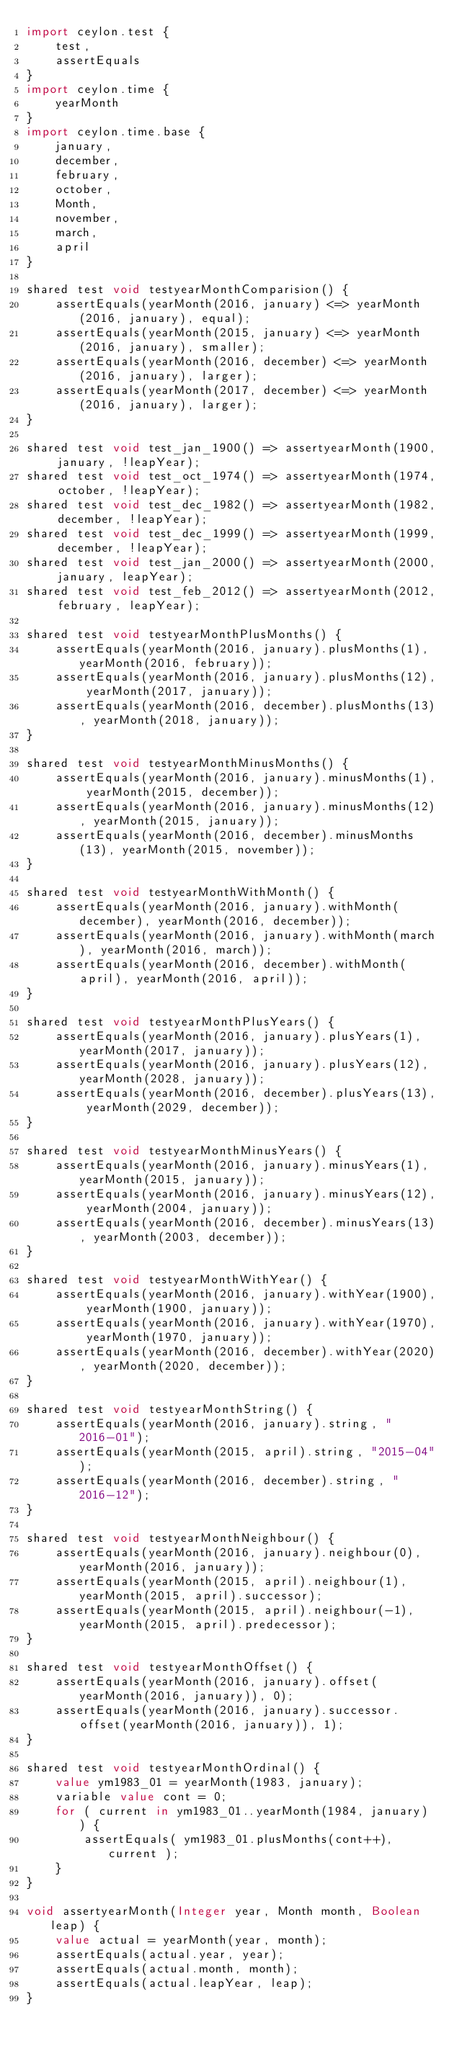Convert code to text. <code><loc_0><loc_0><loc_500><loc_500><_Ceylon_>import ceylon.test {
    test,
    assertEquals
}
import ceylon.time {
    yearMonth
}
import ceylon.time.base {
    january,
    december,
    february,
    october,
    Month,
    november,
    march,
    april
}

shared test void testyearMonthComparision() {
    assertEquals(yearMonth(2016, january) <=> yearMonth(2016, january), equal);
    assertEquals(yearMonth(2015, january) <=> yearMonth(2016, january), smaller);
    assertEquals(yearMonth(2016, december) <=> yearMonth(2016, january), larger);
    assertEquals(yearMonth(2017, december) <=> yearMonth(2016, january), larger);
}

shared test void test_jan_1900() => assertyearMonth(1900, january, !leapYear);
shared test void test_oct_1974() => assertyearMonth(1974, october, !leapYear);
shared test void test_dec_1982() => assertyearMonth(1982, december, !leapYear);
shared test void test_dec_1999() => assertyearMonth(1999, december, !leapYear);
shared test void test_jan_2000() => assertyearMonth(2000, january, leapYear);
shared test void test_feb_2012() => assertyearMonth(2012, february, leapYear);

shared test void testyearMonthPlusMonths() {
    assertEquals(yearMonth(2016, january).plusMonths(1), yearMonth(2016, february));
    assertEquals(yearMonth(2016, january).plusMonths(12), yearMonth(2017, january));
    assertEquals(yearMonth(2016, december).plusMonths(13), yearMonth(2018, january));
}

shared test void testyearMonthMinusMonths() {
    assertEquals(yearMonth(2016, january).minusMonths(1), yearMonth(2015, december));
    assertEquals(yearMonth(2016, january).minusMonths(12), yearMonth(2015, january));
    assertEquals(yearMonth(2016, december).minusMonths(13), yearMonth(2015, november));
}

shared test void testyearMonthWithMonth() {
    assertEquals(yearMonth(2016, january).withMonth(december), yearMonth(2016, december));
    assertEquals(yearMonth(2016, january).withMonth(march), yearMonth(2016, march));
    assertEquals(yearMonth(2016, december).withMonth(april), yearMonth(2016, april));
}

shared test void testyearMonthPlusYears() {
    assertEquals(yearMonth(2016, january).plusYears(1), yearMonth(2017, january));
    assertEquals(yearMonth(2016, january).plusYears(12), yearMonth(2028, january));
    assertEquals(yearMonth(2016, december).plusYears(13), yearMonth(2029, december));
}

shared test void testyearMonthMinusYears() {
    assertEquals(yearMonth(2016, january).minusYears(1), yearMonth(2015, january));
    assertEquals(yearMonth(2016, january).minusYears(12), yearMonth(2004, january));
    assertEquals(yearMonth(2016, december).minusYears(13), yearMonth(2003, december));
}

shared test void testyearMonthWithYear() {
    assertEquals(yearMonth(2016, january).withYear(1900), yearMonth(1900, january));
    assertEquals(yearMonth(2016, january).withYear(1970), yearMonth(1970, january));
    assertEquals(yearMonth(2016, december).withYear(2020), yearMonth(2020, december));
}

shared test void testyearMonthString() {
    assertEquals(yearMonth(2016, january).string, "2016-01");
    assertEquals(yearMonth(2015, april).string, "2015-04");
    assertEquals(yearMonth(2016, december).string, "2016-12");
}

shared test void testyearMonthNeighbour() {
    assertEquals(yearMonth(2016, january).neighbour(0), yearMonth(2016, january));
    assertEquals(yearMonth(2015, april).neighbour(1), yearMonth(2015, april).successor);
    assertEquals(yearMonth(2015, april).neighbour(-1), yearMonth(2015, april).predecessor);
}

shared test void testyearMonthOffset() {
    assertEquals(yearMonth(2016, january).offset(yearMonth(2016, january)), 0);
    assertEquals(yearMonth(2016, january).successor.offset(yearMonth(2016, january)), 1);
}

shared test void testyearMonthOrdinal() {
    value ym1983_01 = yearMonth(1983, january);
    variable value cont = 0;
    for ( current in ym1983_01..yearMonth(1984, january) ) {
        assertEquals( ym1983_01.plusMonths(cont++), current );
    }
}

void assertyearMonth(Integer year, Month month, Boolean leap) {
    value actual = yearMonth(year, month);
    assertEquals(actual.year, year);
    assertEquals(actual.month, month);
    assertEquals(actual.leapYear, leap);
}
</code> 